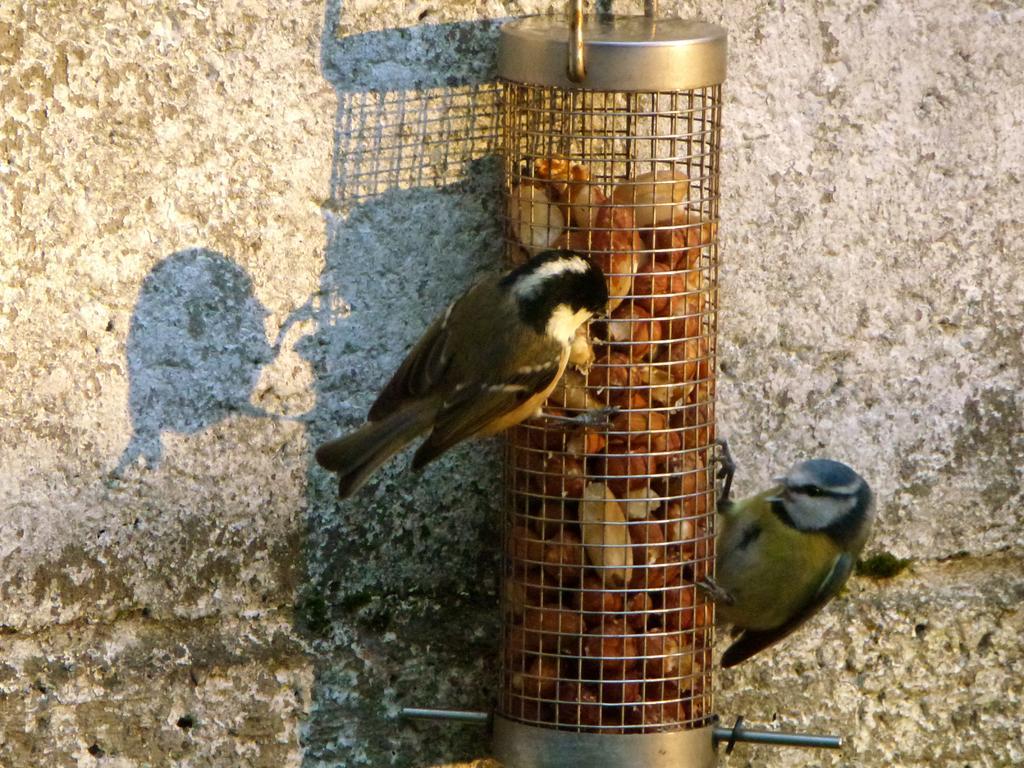Can you describe this image briefly? In this image there are food items in a metal object on which there are birds. In the background of the image there is a wall. 